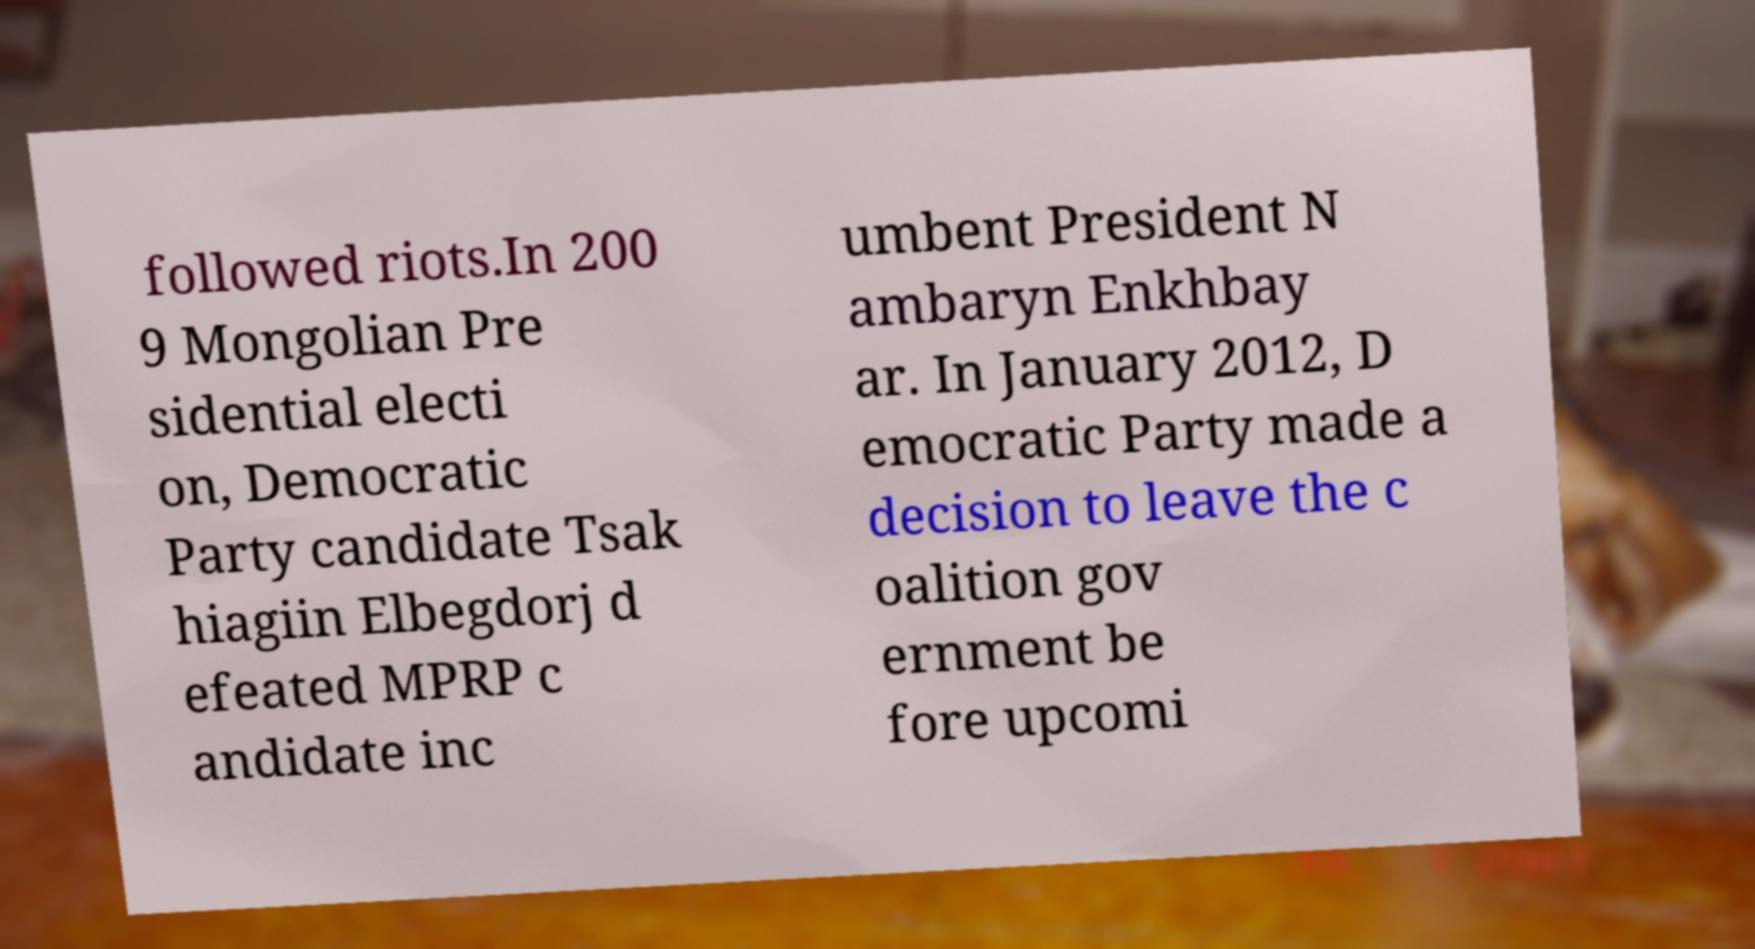There's text embedded in this image that I need extracted. Can you transcribe it verbatim? followed riots.In 200 9 Mongolian Pre sidential electi on, Democratic Party candidate Tsak hiagiin Elbegdorj d efeated MPRP c andidate inc umbent President N ambaryn Enkhbay ar. In January 2012, D emocratic Party made a decision to leave the c oalition gov ernment be fore upcomi 